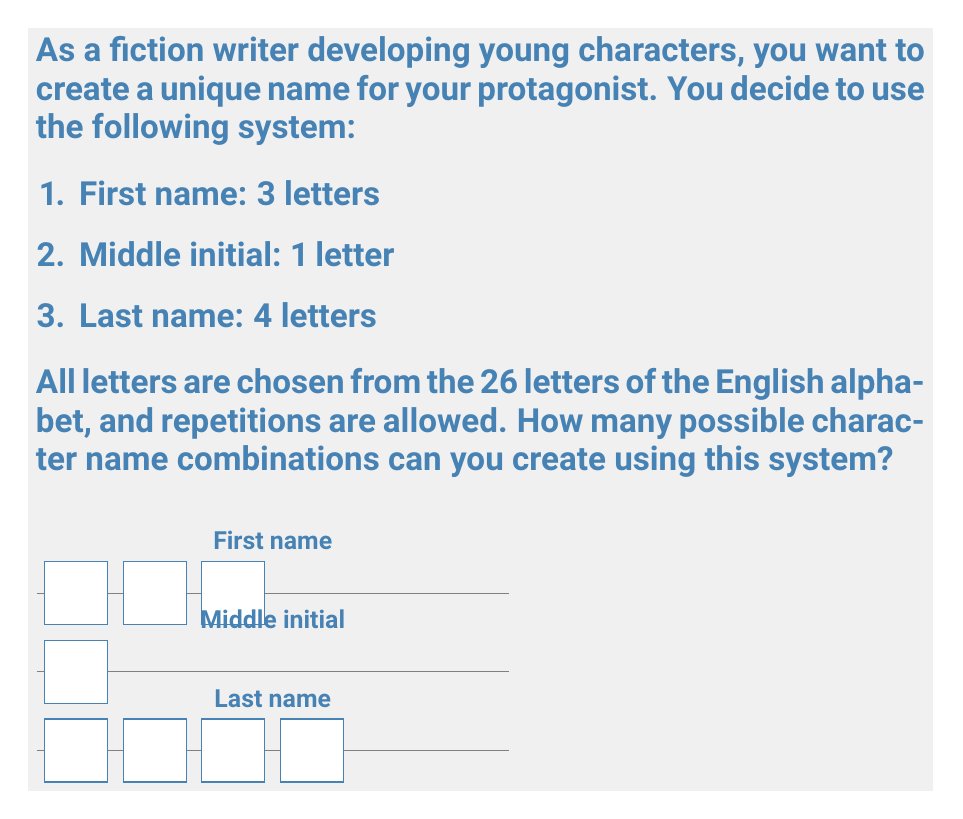Show me your answer to this math problem. Let's break this down step-by-step:

1. First name (3 letters):
   - For each letter, we have 26 choices.
   - We can use the multiplication principle since the choices are independent.
   - Number of possibilities for the first name = $26 \times 26 \times 26 = 26^3$

2. Middle initial (1 letter):
   - We have 26 choices for the middle initial.
   - Number of possibilities for the middle initial = $26^1 = 26$

3. Last name (4 letters):
   - Similar to the first name, we have 26 choices for each letter.
   - Number of possibilities for the last name = $26 \times 26 \times 26 \times 26 = 26^4$

4. Total number of combinations:
   - We use the multiplication principle again to combine all parts of the name.
   - Total combinations = (First name possibilities) × (Middle initial possibilities) × (Last name possibilities)
   - Total combinations = $26^3 \times 26^1 \times 26^4$
   
5. Simplifying the expression:
   - Total combinations = $26^{3+1+4} = 26^8$

6. Calculating the final result:
   - $26^8 = 208,827,064,576$

Therefore, the total number of possible character name combinations is 208,827,064,576.
Answer: $26^8 = 208,827,064,576$ 